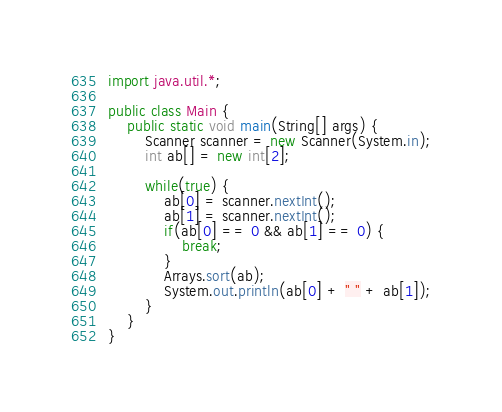Convert code to text. <code><loc_0><loc_0><loc_500><loc_500><_Java_>import java.util.*; 

public class Main {
    public static void main(String[] args) {
        Scanner scanner = new Scanner(System.in);
        int ab[] = new int[2];

        while(true) {
            ab[0] = scanner.nextInt();
            ab[1] = scanner.nextInt();
            if(ab[0] == 0 && ab[1] == 0) {
                break;
            }
            Arrays.sort(ab);
            System.out.println(ab[0] + " " + ab[1]);
        }
    }
}</code> 